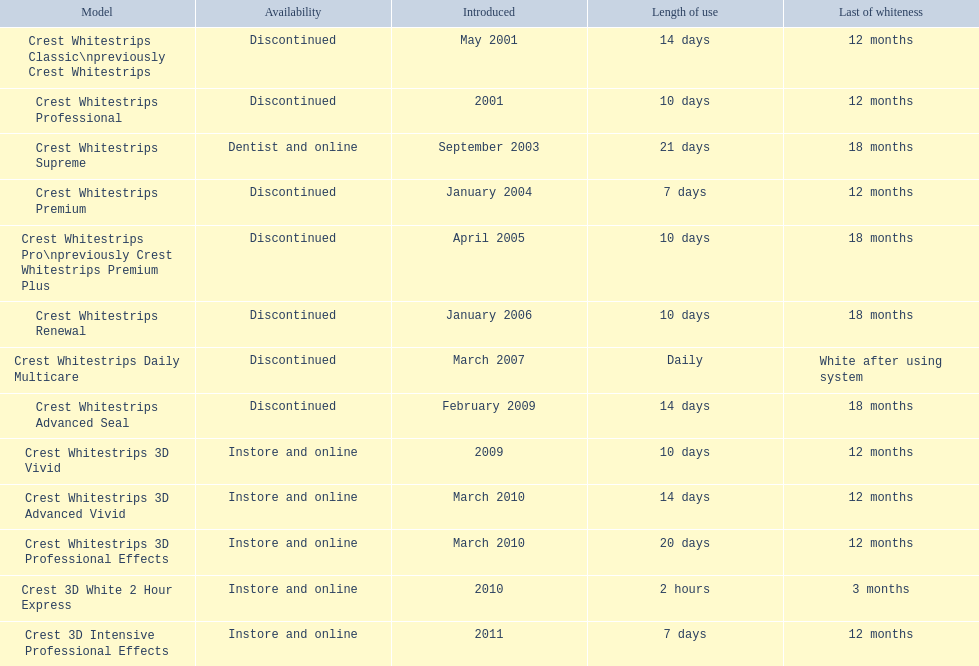Which versions are still obtainable? Crest Whitestrips Supreme, Crest Whitestrips 3D Vivid, Crest Whitestrips 3D Advanced Vivid, Crest Whitestrips 3D Professional Effects, Crest 3D White 2 Hour Express, Crest 3D Intensive Professional Effects. Of these, which were presented earlier than 2011? Crest Whitestrips Supreme, Crest Whitestrips 3D Vivid, Crest Whitestrips 3D Advanced Vivid, Crest Whitestrips 3D Professional Effects, Crest 3D White 2 Hour Express. Among these versions, which ones had to be employed for at least 14 days? Crest Whitestrips Supreme, Crest Whitestrips 3D Advanced Vivid, Crest Whitestrips 3D Professional Effects. Which of these endured more than 12 months? Crest Whitestrips Supreme. 